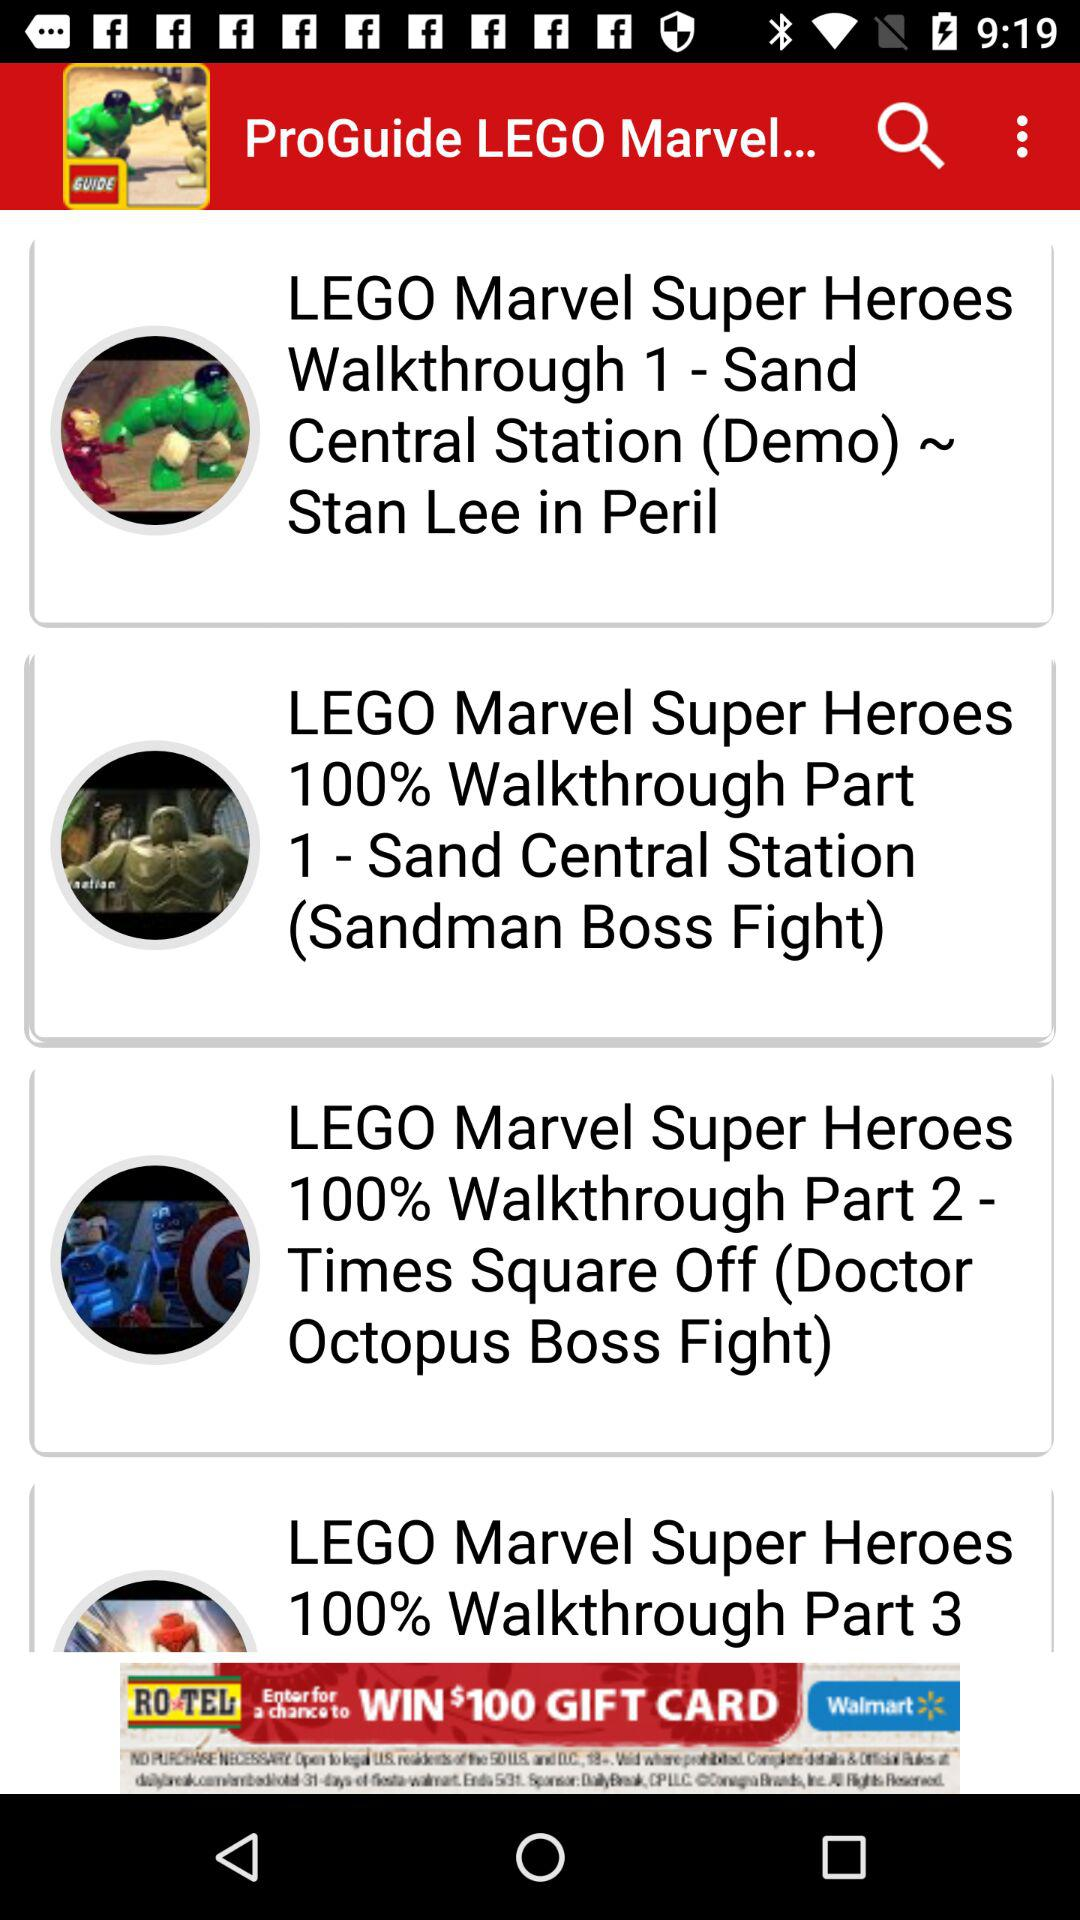Who is this application powered by?
When the provided information is insufficient, respond with <no answer>. <no answer> 